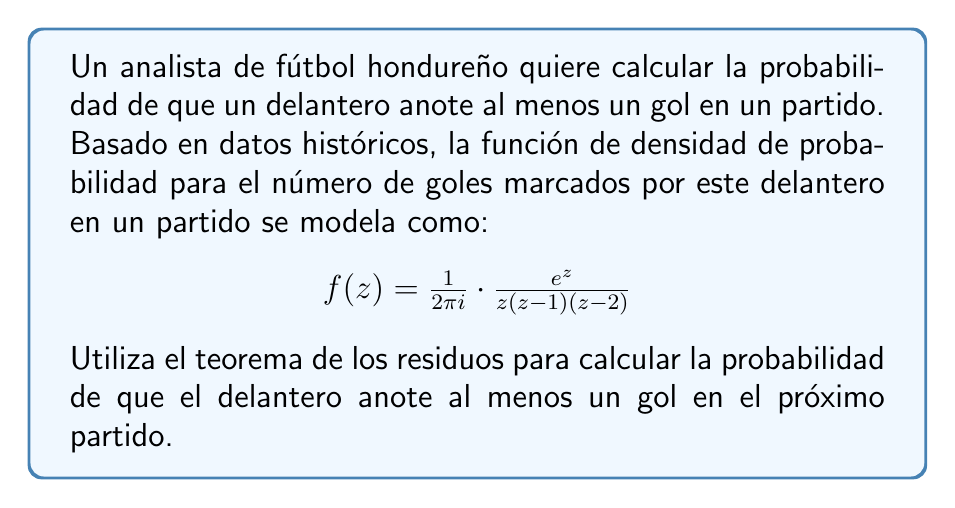Give your solution to this math problem. Para resolver este problema, seguiremos estos pasos:

1) La probabilidad de anotar al menos un gol es igual a 1 menos la probabilidad de no anotar ningún gol. Matemáticamente, esto se expresa como:

   $P(\text{al menos un gol}) = 1 - P(\text{ningún gol})$

2) La probabilidad de anotar exactamente $n$ goles está dada por la integral:

   $P(n \text{ goles}) = \frac{1}{2\pi i} \oint_C \frac{e^z}{z^{n+1}(z-1)(z-2)} dz$

   donde $C$ es un contorno que encierra el origen.

3) Para $n = 0$ (ningún gol), tenemos:

   $P(0 \text{ goles}) = \frac{1}{2\pi i} \oint_C \frac{e^z}{z(z-1)(z-2)} dz$

4) Aplicando el teorema de los residuos:

   $P(0 \text{ goles}) = \text{Res}_{z=0} \frac{e^z}{z(z-1)(z-2)} + \text{Res}_{z=1} \frac{e^z}{z(z-1)(z-2)} + \text{Res}_{z=2} \frac{e^z}{z(z-1)(z-2)}$

5) Calculemos cada residuo:

   $\text{Res}_{z=0} = \frac{e^0}{(0-1)(0-2)} = \frac{1}{2}$

   $\text{Res}_{z=1} = \frac{e^1}{1(1-2)} = -e$

   $\text{Res}_{z=2} = \frac{e^2}{2(2-1)} = e^2$

6) Sumando los residuos:

   $P(0 \text{ goles}) = \frac{1}{2} - e + e^2$

7) Por lo tanto, la probabilidad de anotar al menos un gol es:

   $P(\text{al menos un gol}) = 1 - (\frac{1}{2} - e + e^2) = \frac{1}{2} + e - e^2$
Answer: $\frac{1}{2} + e - e^2$ 